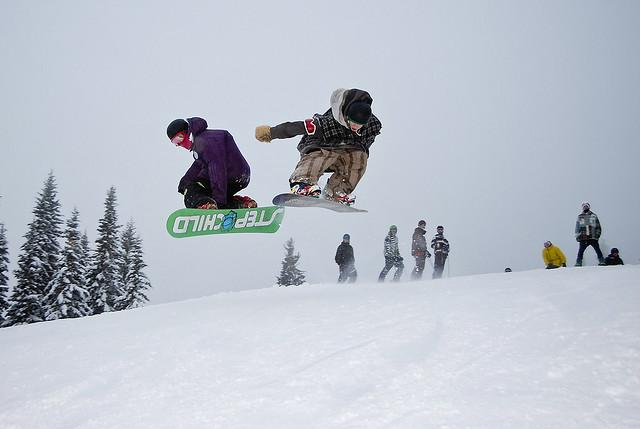Which famous person fits the description on the bottom of the board? no idea 